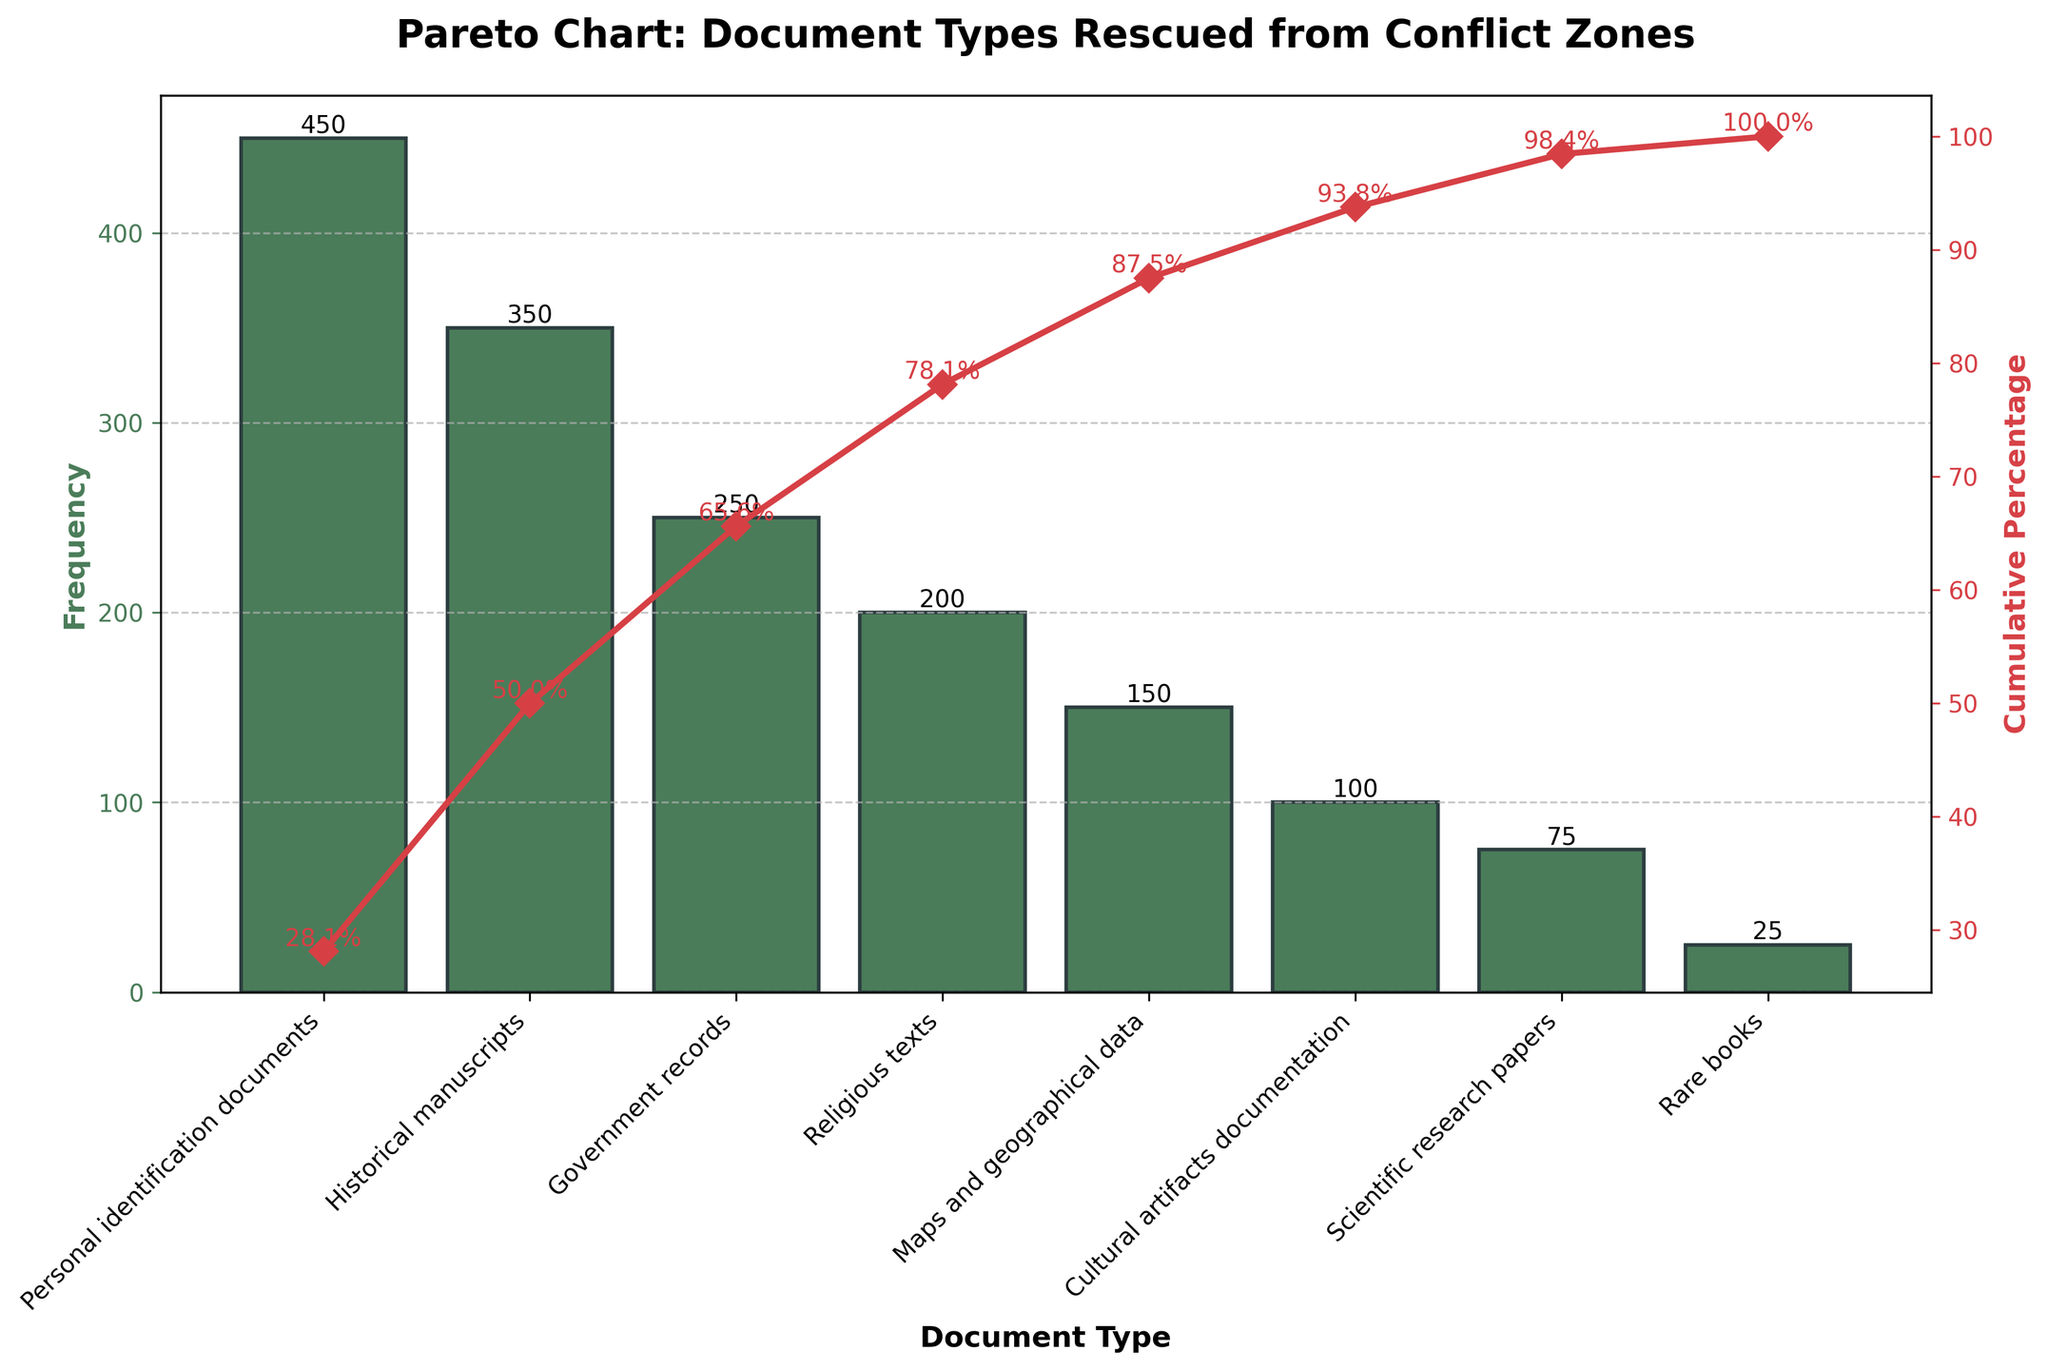What's the title of the figure? The title of the figure is displayed at the top and reads, "Pareto Chart: Document Types Rescued from Conflict Zones".
Answer: Pareto Chart: Document Types Rescued from Conflict Zones What is the most frequent type of document rescued? The highest bar on the chart indicates the most frequent type of document. The bar for "Personal identification documents" is the tallest, showing a frequency of 450.
Answer: Personal identification documents Which document type has the lowest frequency? The shortest bar on the chart represents the document type with the lowest frequency. The bar for "Rare books" is the shortest, showing a frequency of 25.
Answer: Rare books What's the frequency of "Historical manuscripts"? Locate the bar labeled "Historical manuscripts" and look at its height. The frequency is indicated at the top of the bar, which shows 350.
Answer: 350 What is the cumulative percentage of "Religious texts" and the types of documents classified before it? The cumulative percentage up to and including "Religious texts" is displayed by the plotted line on the secondary axis. Look at the line corresponding to "Religious texts", which is labeled as 78.13%.
Answer: 78.13% Compare the cumulative percentages of "Government records" and "Maps and geographical data". Which one is higher? The cumulative percentage for "Government records" is shown as 65.63%, and for "Maps and geographical data" it is 87.50%. Since 87.50% is higher than 65.63%, "Maps and geographical data" has the higher cumulative percentage.
Answer: Maps and geographical data How many types of documents account for at least 78.13% of the total rescues? To determine how many document types account for at least 78.13%, look at the cumulative percentage values. The document type "Religious texts" has a cumulative percentage of 78.13%, and the types before it are "Personal identification documents", "Historical manuscripts", and "Government records", making it four types in total.
Answer: 4 If we combine the frequencies of "Maps and geographical data" and "Cultural artifacts documentation", what is the new frequency? To find the combined frequency, add the frequencies of "Maps and geographical data" (150) and "Cultural artifacts documentation" (100). The total is 150 + 100 = 250.
Answer: 250 Which document type contributes to crossing the 50% cumulative percentage threshold on the line plot? The cumulative percentage crosses 50% at the point corresponding to "Historical manuscripts", which is labeled as having a cumulative percentage of exactly 50.00%.
Answer: Historical manuscripts What percentage of the total is accounted for by "Scientific research papers" and "Rare books" together? First, determine the frequencies of "Scientific research papers" (75) and "Rare books" (25). Add these frequencies (75 + 25 = 100). Then, look at the cumulative percentage at "Rare books", which is already given as 100%. Therefore, these two types together make up the last 6.25% before reaching 100%.
Answer: 6.25% 